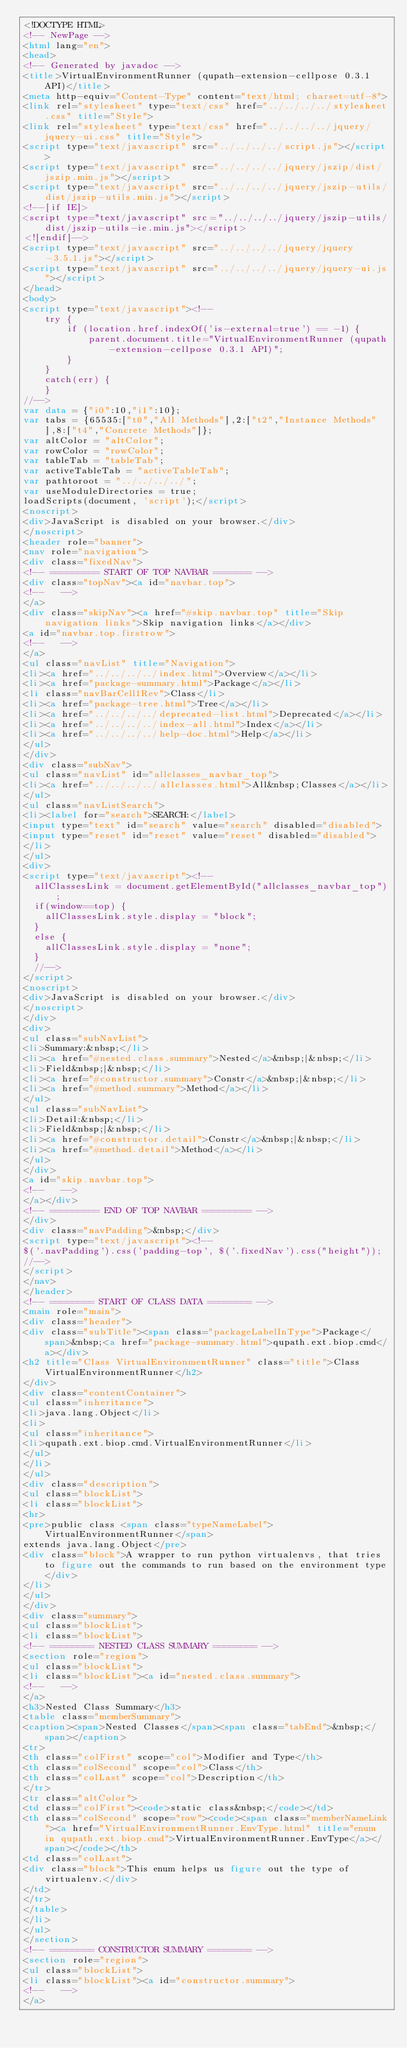<code> <loc_0><loc_0><loc_500><loc_500><_HTML_><!DOCTYPE HTML>
<!-- NewPage -->
<html lang="en">
<head>
<!-- Generated by javadoc -->
<title>VirtualEnvironmentRunner (qupath-extension-cellpose 0.3.1 API)</title>
<meta http-equiv="Content-Type" content="text/html; charset=utf-8">
<link rel="stylesheet" type="text/css" href="../../../../stylesheet.css" title="Style">
<link rel="stylesheet" type="text/css" href="../../../../jquery/jquery-ui.css" title="Style">
<script type="text/javascript" src="../../../../script.js"></script>
<script type="text/javascript" src="../../../../jquery/jszip/dist/jszip.min.js"></script>
<script type="text/javascript" src="../../../../jquery/jszip-utils/dist/jszip-utils.min.js"></script>
<!--[if IE]>
<script type="text/javascript" src="../../../../jquery/jszip-utils/dist/jszip-utils-ie.min.js"></script>
<![endif]-->
<script type="text/javascript" src="../../../../jquery/jquery-3.5.1.js"></script>
<script type="text/javascript" src="../../../../jquery/jquery-ui.js"></script>
</head>
<body>
<script type="text/javascript"><!--
    try {
        if (location.href.indexOf('is-external=true') == -1) {
            parent.document.title="VirtualEnvironmentRunner (qupath-extension-cellpose 0.3.1 API)";
        }
    }
    catch(err) {
    }
//-->
var data = {"i0":10,"i1":10};
var tabs = {65535:["t0","All Methods"],2:["t2","Instance Methods"],8:["t4","Concrete Methods"]};
var altColor = "altColor";
var rowColor = "rowColor";
var tableTab = "tableTab";
var activeTableTab = "activeTableTab";
var pathtoroot = "../../../../";
var useModuleDirectories = true;
loadScripts(document, 'script');</script>
<noscript>
<div>JavaScript is disabled on your browser.</div>
</noscript>
<header role="banner">
<nav role="navigation">
<div class="fixedNav">
<!-- ========= START OF TOP NAVBAR ======= -->
<div class="topNav"><a id="navbar.top">
<!--   -->
</a>
<div class="skipNav"><a href="#skip.navbar.top" title="Skip navigation links">Skip navigation links</a></div>
<a id="navbar.top.firstrow">
<!--   -->
</a>
<ul class="navList" title="Navigation">
<li><a href="../../../../index.html">Overview</a></li>
<li><a href="package-summary.html">Package</a></li>
<li class="navBarCell1Rev">Class</li>
<li><a href="package-tree.html">Tree</a></li>
<li><a href="../../../../deprecated-list.html">Deprecated</a></li>
<li><a href="../../../../index-all.html">Index</a></li>
<li><a href="../../../../help-doc.html">Help</a></li>
</ul>
</div>
<div class="subNav">
<ul class="navList" id="allclasses_navbar_top">
<li><a href="../../../../allclasses.html">All&nbsp;Classes</a></li>
</ul>
<ul class="navListSearch">
<li><label for="search">SEARCH:</label>
<input type="text" id="search" value="search" disabled="disabled">
<input type="reset" id="reset" value="reset" disabled="disabled">
</li>
</ul>
<div>
<script type="text/javascript"><!--
  allClassesLink = document.getElementById("allclasses_navbar_top");
  if(window==top) {
    allClassesLink.style.display = "block";
  }
  else {
    allClassesLink.style.display = "none";
  }
  //-->
</script>
<noscript>
<div>JavaScript is disabled on your browser.</div>
</noscript>
</div>
<div>
<ul class="subNavList">
<li>Summary:&nbsp;</li>
<li><a href="#nested.class.summary">Nested</a>&nbsp;|&nbsp;</li>
<li>Field&nbsp;|&nbsp;</li>
<li><a href="#constructor.summary">Constr</a>&nbsp;|&nbsp;</li>
<li><a href="#method.summary">Method</a></li>
</ul>
<ul class="subNavList">
<li>Detail:&nbsp;</li>
<li>Field&nbsp;|&nbsp;</li>
<li><a href="#constructor.detail">Constr</a>&nbsp;|&nbsp;</li>
<li><a href="#method.detail">Method</a></li>
</ul>
</div>
<a id="skip.navbar.top">
<!--   -->
</a></div>
<!-- ========= END OF TOP NAVBAR ========= -->
</div>
<div class="navPadding">&nbsp;</div>
<script type="text/javascript"><!--
$('.navPadding').css('padding-top', $('.fixedNav').css("height"));
//-->
</script>
</nav>
</header>
<!-- ======== START OF CLASS DATA ======== -->
<main role="main">
<div class="header">
<div class="subTitle"><span class="packageLabelInType">Package</span>&nbsp;<a href="package-summary.html">qupath.ext.biop.cmd</a></div>
<h2 title="Class VirtualEnvironmentRunner" class="title">Class VirtualEnvironmentRunner</h2>
</div>
<div class="contentContainer">
<ul class="inheritance">
<li>java.lang.Object</li>
<li>
<ul class="inheritance">
<li>qupath.ext.biop.cmd.VirtualEnvironmentRunner</li>
</ul>
</li>
</ul>
<div class="description">
<ul class="blockList">
<li class="blockList">
<hr>
<pre>public class <span class="typeNameLabel">VirtualEnvironmentRunner</span>
extends java.lang.Object</pre>
<div class="block">A wrapper to run python virtualenvs, that tries to figure out the commands to run based on the environment type</div>
</li>
</ul>
</div>
<div class="summary">
<ul class="blockList">
<li class="blockList">
<!-- ======== NESTED CLASS SUMMARY ======== -->
<section role="region">
<ul class="blockList">
<li class="blockList"><a id="nested.class.summary">
<!--   -->
</a>
<h3>Nested Class Summary</h3>
<table class="memberSummary">
<caption><span>Nested Classes</span><span class="tabEnd">&nbsp;</span></caption>
<tr>
<th class="colFirst" scope="col">Modifier and Type</th>
<th class="colSecond" scope="col">Class</th>
<th class="colLast" scope="col">Description</th>
</tr>
<tr class="altColor">
<td class="colFirst"><code>static class&nbsp;</code></td>
<th class="colSecond" scope="row"><code><span class="memberNameLink"><a href="VirtualEnvironmentRunner.EnvType.html" title="enum in qupath.ext.biop.cmd">VirtualEnvironmentRunner.EnvType</a></span></code></th>
<td class="colLast">
<div class="block">This enum helps us figure out the type of virtualenv.</div>
</td>
</tr>
</table>
</li>
</ul>
</section>
<!-- ======== CONSTRUCTOR SUMMARY ======== -->
<section role="region">
<ul class="blockList">
<li class="blockList"><a id="constructor.summary">
<!--   -->
</a></code> 